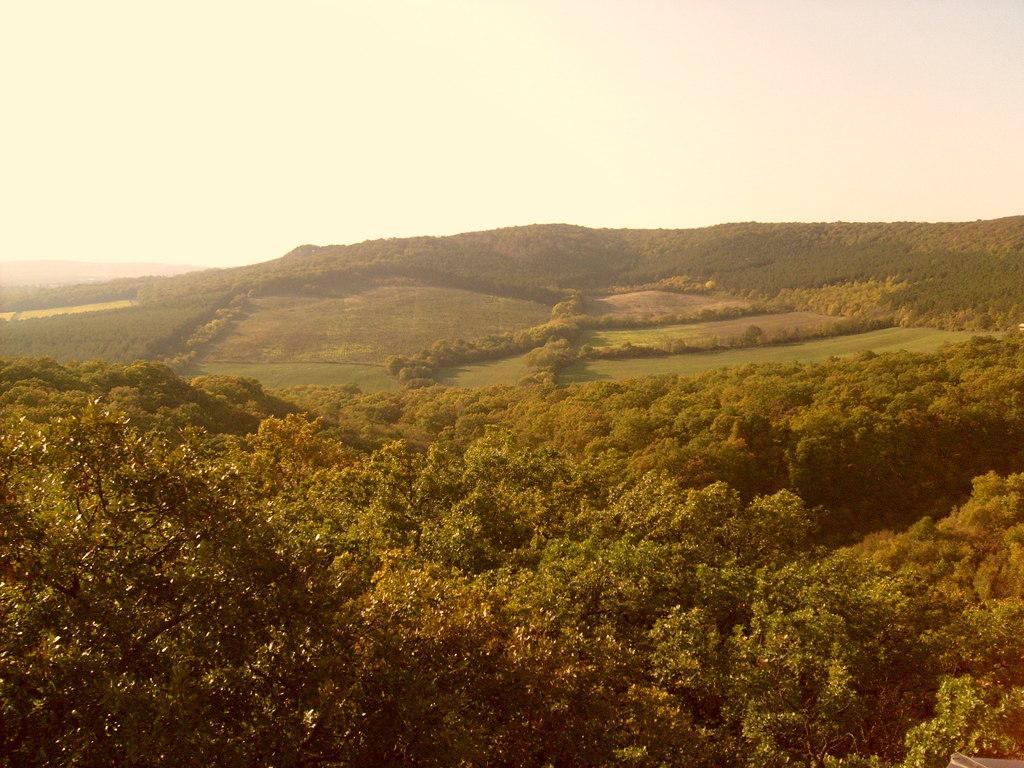Please provide a concise description of this image. In this image it seems like it is a scenery. At the bottom we can see the trees. In the background there are hills. At the top there is sky. 